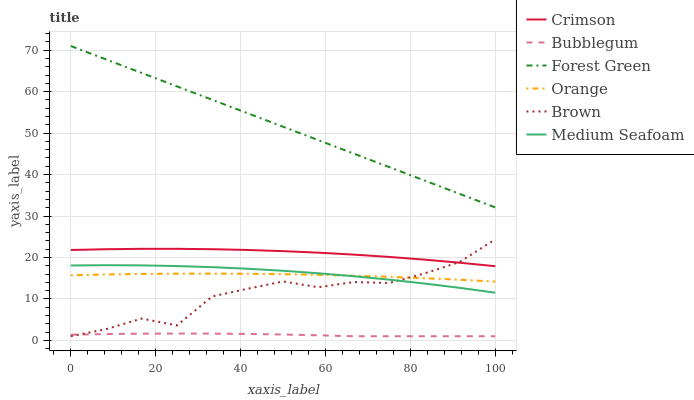Does Bubblegum have the minimum area under the curve?
Answer yes or no. Yes. Does Forest Green have the maximum area under the curve?
Answer yes or no. Yes. Does Orange have the minimum area under the curve?
Answer yes or no. No. Does Orange have the maximum area under the curve?
Answer yes or no. No. Is Forest Green the smoothest?
Answer yes or no. Yes. Is Brown the roughest?
Answer yes or no. Yes. Is Bubblegum the smoothest?
Answer yes or no. No. Is Bubblegum the roughest?
Answer yes or no. No. Does Brown have the lowest value?
Answer yes or no. Yes. Does Orange have the lowest value?
Answer yes or no. No. Does Forest Green have the highest value?
Answer yes or no. Yes. Does Orange have the highest value?
Answer yes or no. No. Is Bubblegum less than Forest Green?
Answer yes or no. Yes. Is Crimson greater than Orange?
Answer yes or no. Yes. Does Brown intersect Crimson?
Answer yes or no. Yes. Is Brown less than Crimson?
Answer yes or no. No. Is Brown greater than Crimson?
Answer yes or no. No. Does Bubblegum intersect Forest Green?
Answer yes or no. No. 